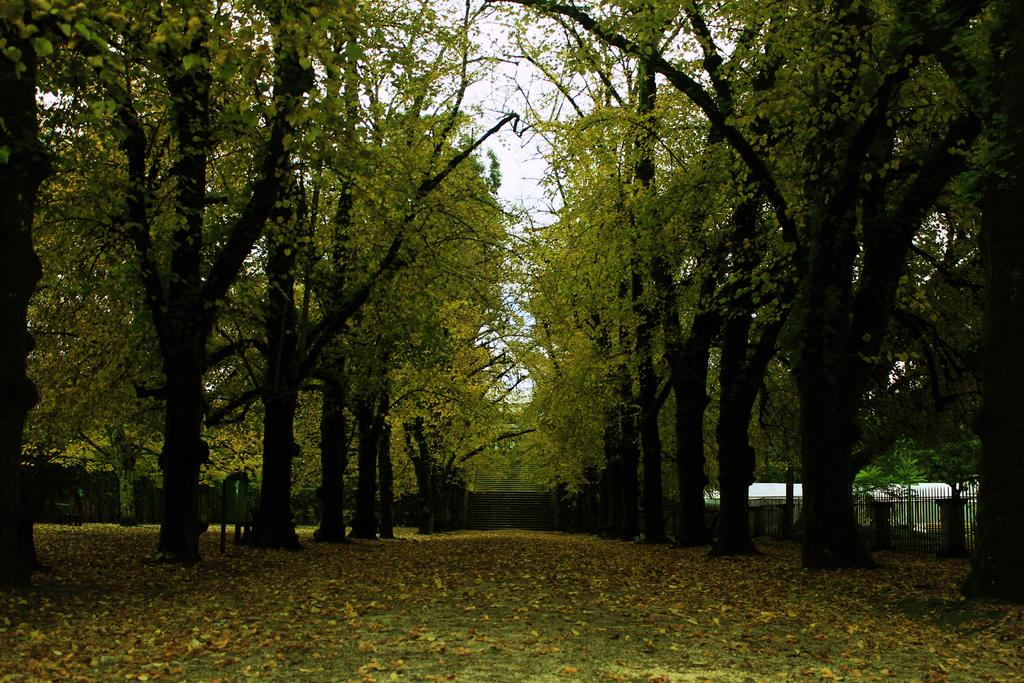What type of natural barrier is present in the image? There is a wooden fence in the image. What is located within the wooden fence? There are trees inside the wooden fence in the image. What can be seen on the ground in the image? There are dry leaves on the surface in the image. What type of sign is hanging from the trees in the image? There is no sign present in the image; it only features trees and dry leaves within a wooden fence. What flavor of jam can be seen on the leaves in the image? There is no jam present in the image; it only features trees and dry leaves within a wooden fence. 